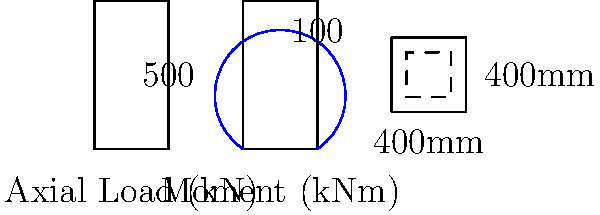As a game developer working on a realistic structural simulation, you need to calculate the required reinforcement area for a concrete column. Given a 400mm x 400mm square column subjected to an axial load of 500 kN and a maximum moment of 100 kNm, determine the minimum area of longitudinal reinforcement required. Assume concrete strength $f'_c = 30$ MPa and steel yield strength $f_y = 400$ MPa. Use the simplified method for column design. To calculate the required reinforcement area, we'll follow these steps:

1. Calculate the gross area of the column:
   $A_g = 400 \text{ mm} \times 400 \text{ mm} = 160,000 \text{ mm}^2$

2. Determine the minimum reinforcement ratio:
   $\rho_{min} = 0.01$ (1% of gross area)

3. Calculate the minimum reinforcement area:
   $A_{s,min} = \rho_{min} \times A_g = 0.01 \times 160,000 = 1,600 \text{ mm}^2$

4. Calculate the axial load capacity of the concrete:
   $P_0 = 0.85 \times f'_c \times (A_g - A_{s,min}) + f_y \times A_{s,min}$
   $P_0 = 0.85 \times 30 \times (160,000 - 1,600) + 400 \times 1,600 = 4,728,800 \text{ N} = 4,728.8 \text{ kN}$

5. Calculate the eccentricity:
   $e = \frac{M}{P} = \frac{100 \text{ kNm}}{500 \text{ kN}} = 0.2 \text{ m} = 200 \text{ mm}$

6. Check if the eccentricity is within the limits:
   $e_{min} = 0.1h = 0.1 \times 400 = 40 \text{ mm}$
   $e_{max} = 0.6h = 0.6 \times 400 = 240 \text{ mm}$
   $40 \text{ mm} < 200 \text{ mm} < 240 \text{ mm}$, so the eccentricity is within limits.

7. Calculate the required reinforcement area using the simplified method:
   $A_s = \frac{P}{0.67f_y} \times (1 + \frac{6e}{h})$
   $A_s = \frac{500,000}{0.67 \times 400} \times (1 + \frac{6 \times 200}{400}) = 4,663 \text{ mm}^2$

8. Compare the calculated area with the minimum required area:
   $A_s = 4,663 \text{ mm}^2 > A_{s,min} = 1,600 \text{ mm}^2$

Therefore, the required reinforcement area is 4,663 mm².
Answer: 4,663 mm² 